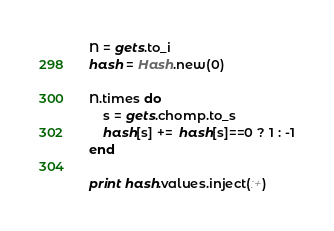<code> <loc_0><loc_0><loc_500><loc_500><_Ruby_>N = gets.to_i
hash = Hash.new(0)

N.times do
	s = gets.chomp.to_s
	hash[s] +=  hash[s]==0 ? 1 : -1
end

print hash.values.inject(:+)</code> 